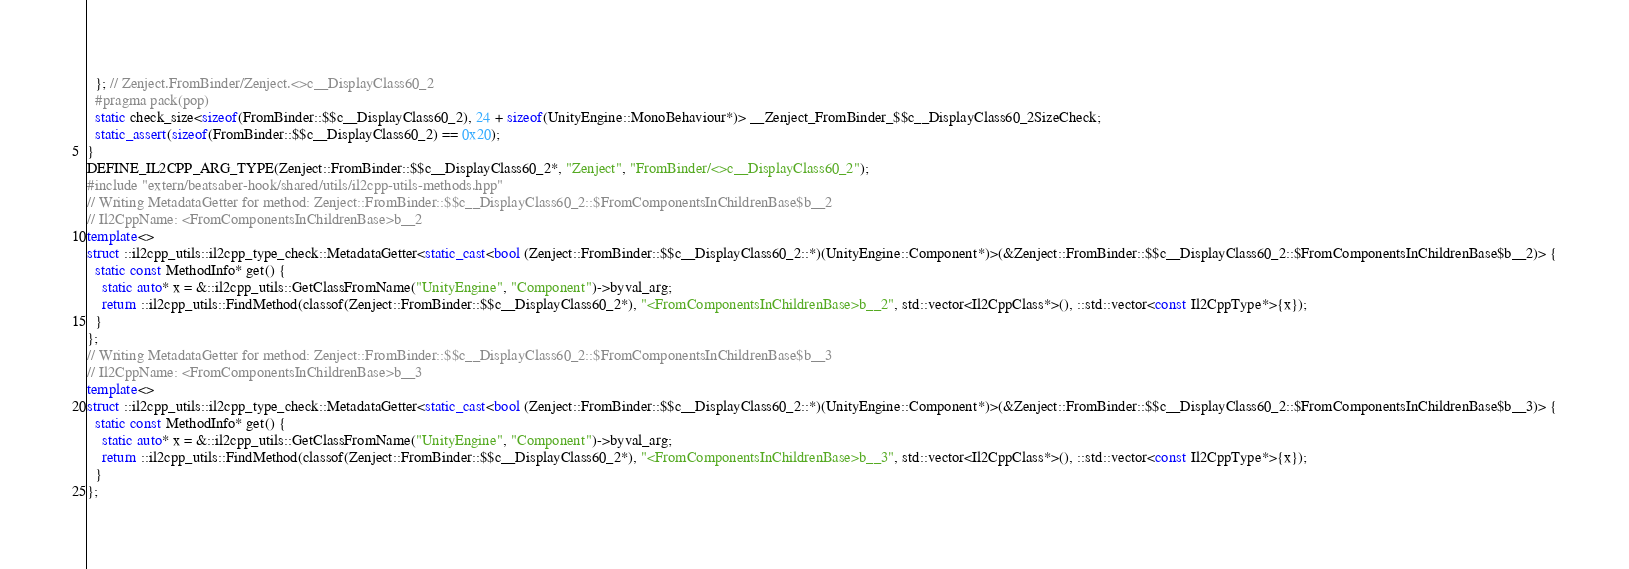Convert code to text. <code><loc_0><loc_0><loc_500><loc_500><_C++_>  }; // Zenject.FromBinder/Zenject.<>c__DisplayClass60_2
  #pragma pack(pop)
  static check_size<sizeof(FromBinder::$$c__DisplayClass60_2), 24 + sizeof(UnityEngine::MonoBehaviour*)> __Zenject_FromBinder_$$c__DisplayClass60_2SizeCheck;
  static_assert(sizeof(FromBinder::$$c__DisplayClass60_2) == 0x20);
}
DEFINE_IL2CPP_ARG_TYPE(Zenject::FromBinder::$$c__DisplayClass60_2*, "Zenject", "FromBinder/<>c__DisplayClass60_2");
#include "extern/beatsaber-hook/shared/utils/il2cpp-utils-methods.hpp"
// Writing MetadataGetter for method: Zenject::FromBinder::$$c__DisplayClass60_2::$FromComponentsInChildrenBase$b__2
// Il2CppName: <FromComponentsInChildrenBase>b__2
template<>
struct ::il2cpp_utils::il2cpp_type_check::MetadataGetter<static_cast<bool (Zenject::FromBinder::$$c__DisplayClass60_2::*)(UnityEngine::Component*)>(&Zenject::FromBinder::$$c__DisplayClass60_2::$FromComponentsInChildrenBase$b__2)> {
  static const MethodInfo* get() {
    static auto* x = &::il2cpp_utils::GetClassFromName("UnityEngine", "Component")->byval_arg;
    return ::il2cpp_utils::FindMethod(classof(Zenject::FromBinder::$$c__DisplayClass60_2*), "<FromComponentsInChildrenBase>b__2", std::vector<Il2CppClass*>(), ::std::vector<const Il2CppType*>{x});
  }
};
// Writing MetadataGetter for method: Zenject::FromBinder::$$c__DisplayClass60_2::$FromComponentsInChildrenBase$b__3
// Il2CppName: <FromComponentsInChildrenBase>b__3
template<>
struct ::il2cpp_utils::il2cpp_type_check::MetadataGetter<static_cast<bool (Zenject::FromBinder::$$c__DisplayClass60_2::*)(UnityEngine::Component*)>(&Zenject::FromBinder::$$c__DisplayClass60_2::$FromComponentsInChildrenBase$b__3)> {
  static const MethodInfo* get() {
    static auto* x = &::il2cpp_utils::GetClassFromName("UnityEngine", "Component")->byval_arg;
    return ::il2cpp_utils::FindMethod(classof(Zenject::FromBinder::$$c__DisplayClass60_2*), "<FromComponentsInChildrenBase>b__3", std::vector<Il2CppClass*>(), ::std::vector<const Il2CppType*>{x});
  }
};</code> 